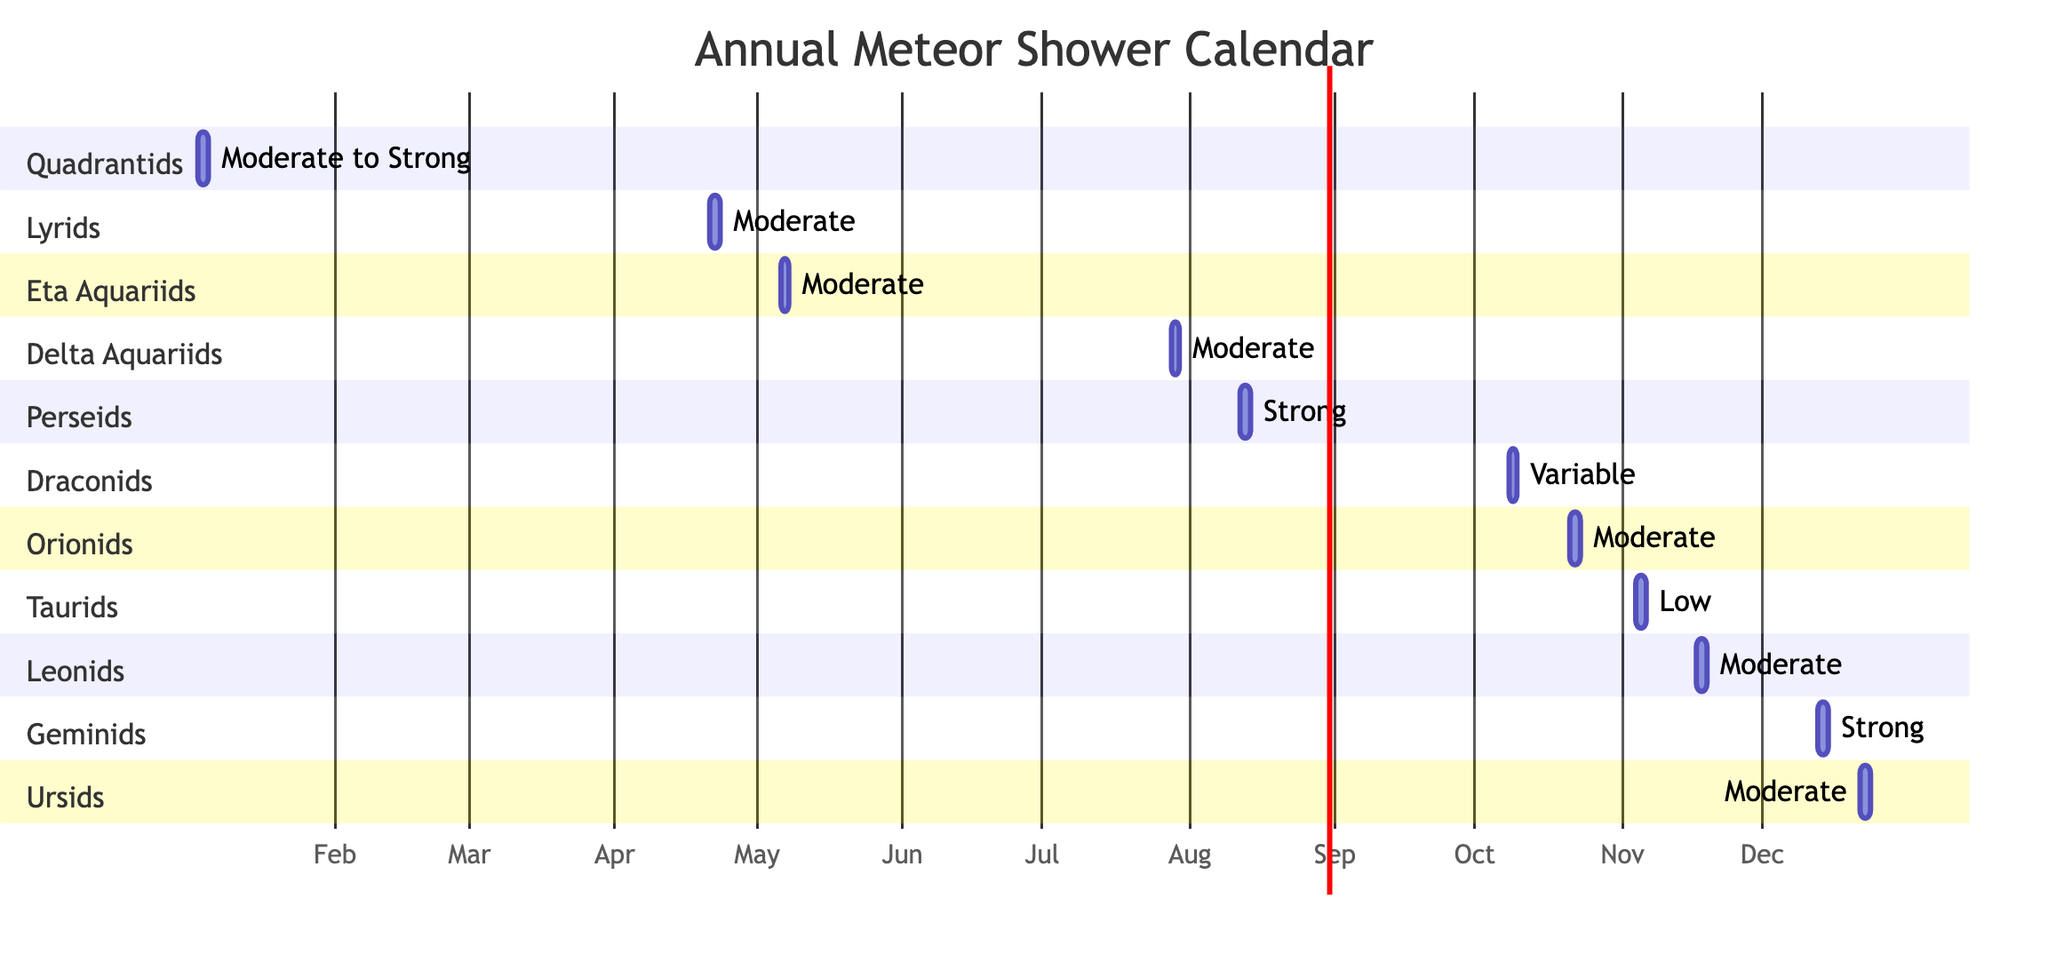What are the peak dates for the Quadrantids meteor shower? The Quadrantids shower peaks on January 3rd, which is specified in the diagram under the section for Quadrantids.
Answer: January 3rd How long does the Perseids meteor shower last? The diagram shows that the Perseids meteor shower lasts for 2 days, as indicated next to the peak date of August 12th.
Answer: 2 days Which meteor shower is noted for having a variable intensity? In the diagram, the Draconids are labeled as having a variable intensity, shown in the section for Draconids.
Answer: Draconids When do the Geminids peak? According to the diagram, the Geminids peak on December 13th, marked in the section dedicated to the Geminids.
Answer: December 13th How many meteor showers occur in November? The diagram illustrates three meteor showers in November: Taurids, Leonids, and the Draconids, bringing the total to three.
Answer: 3 Which meteor shower has the strongest intensity? The Perseids and Geminids are both classified as strong, but Geminids peak on December 13th, which indicates a relative strength in the later months.
Answer: Geminids What is the intensity level of the Lyrids meteor shower? The diagram specifies the Lyrids with a moderate intensity, which is directly mentioned in the section corresponding to Lyrids.
Answer: Moderate How many days do the Eta Aquariids meteor shower last? The diagram shows that the Eta Aquariids meteor shower lasts for 2 days, as indicated next to its peak date of May 6th.
Answer: 2 days What is the peak time for the Orionids? The peak time for the Orionids is indicated as October 21st in the diagram, which directly states the date.
Answer: October 21st 